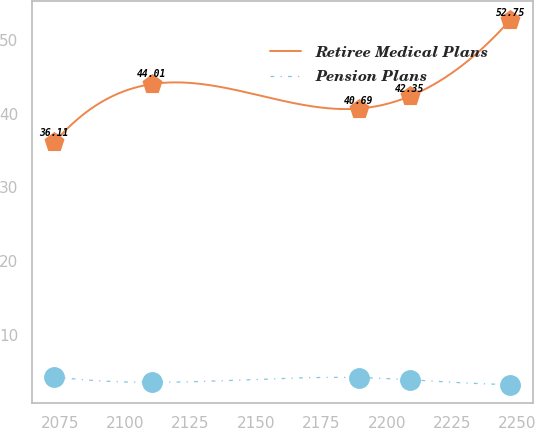<chart> <loc_0><loc_0><loc_500><loc_500><line_chart><ecel><fcel>Retiree Medical Plans<fcel>Pension Plans<nl><fcel>2072.91<fcel>36.11<fcel>4.32<nl><fcel>2110.06<fcel>44.01<fcel>3.55<nl><fcel>2189.2<fcel>40.69<fcel>4.19<nl><fcel>2208.69<fcel>42.35<fcel>3.9<nl><fcel>2247.26<fcel>52.75<fcel>3.25<nl></chart> 